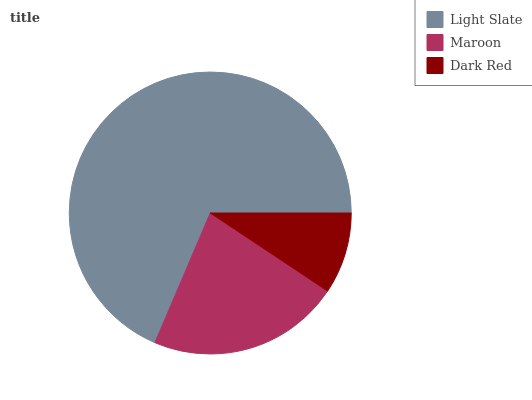Is Dark Red the minimum?
Answer yes or no. Yes. Is Light Slate the maximum?
Answer yes or no. Yes. Is Maroon the minimum?
Answer yes or no. No. Is Maroon the maximum?
Answer yes or no. No. Is Light Slate greater than Maroon?
Answer yes or no. Yes. Is Maroon less than Light Slate?
Answer yes or no. Yes. Is Maroon greater than Light Slate?
Answer yes or no. No. Is Light Slate less than Maroon?
Answer yes or no. No. Is Maroon the high median?
Answer yes or no. Yes. Is Maroon the low median?
Answer yes or no. Yes. Is Dark Red the high median?
Answer yes or no. No. Is Light Slate the low median?
Answer yes or no. No. 